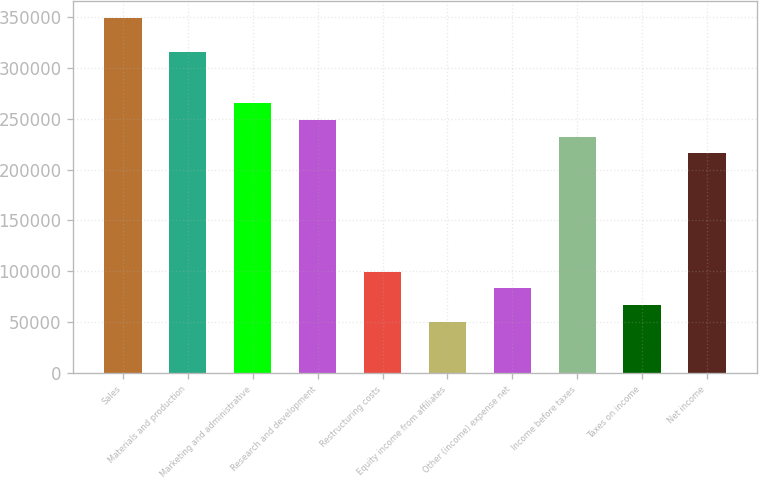Convert chart. <chart><loc_0><loc_0><loc_500><loc_500><bar_chart><fcel>Sales<fcel>Materials and production<fcel>Marketing and administrative<fcel>Research and development<fcel>Restructuring costs<fcel>Equity income from affiliates<fcel>Other (income) expense net<fcel>Income before taxes<fcel>Taxes on income<fcel>Net income<nl><fcel>348808<fcel>315588<fcel>265759<fcel>249149<fcel>99660.8<fcel>49831.4<fcel>83051<fcel>232539<fcel>66441.2<fcel>215929<nl></chart> 